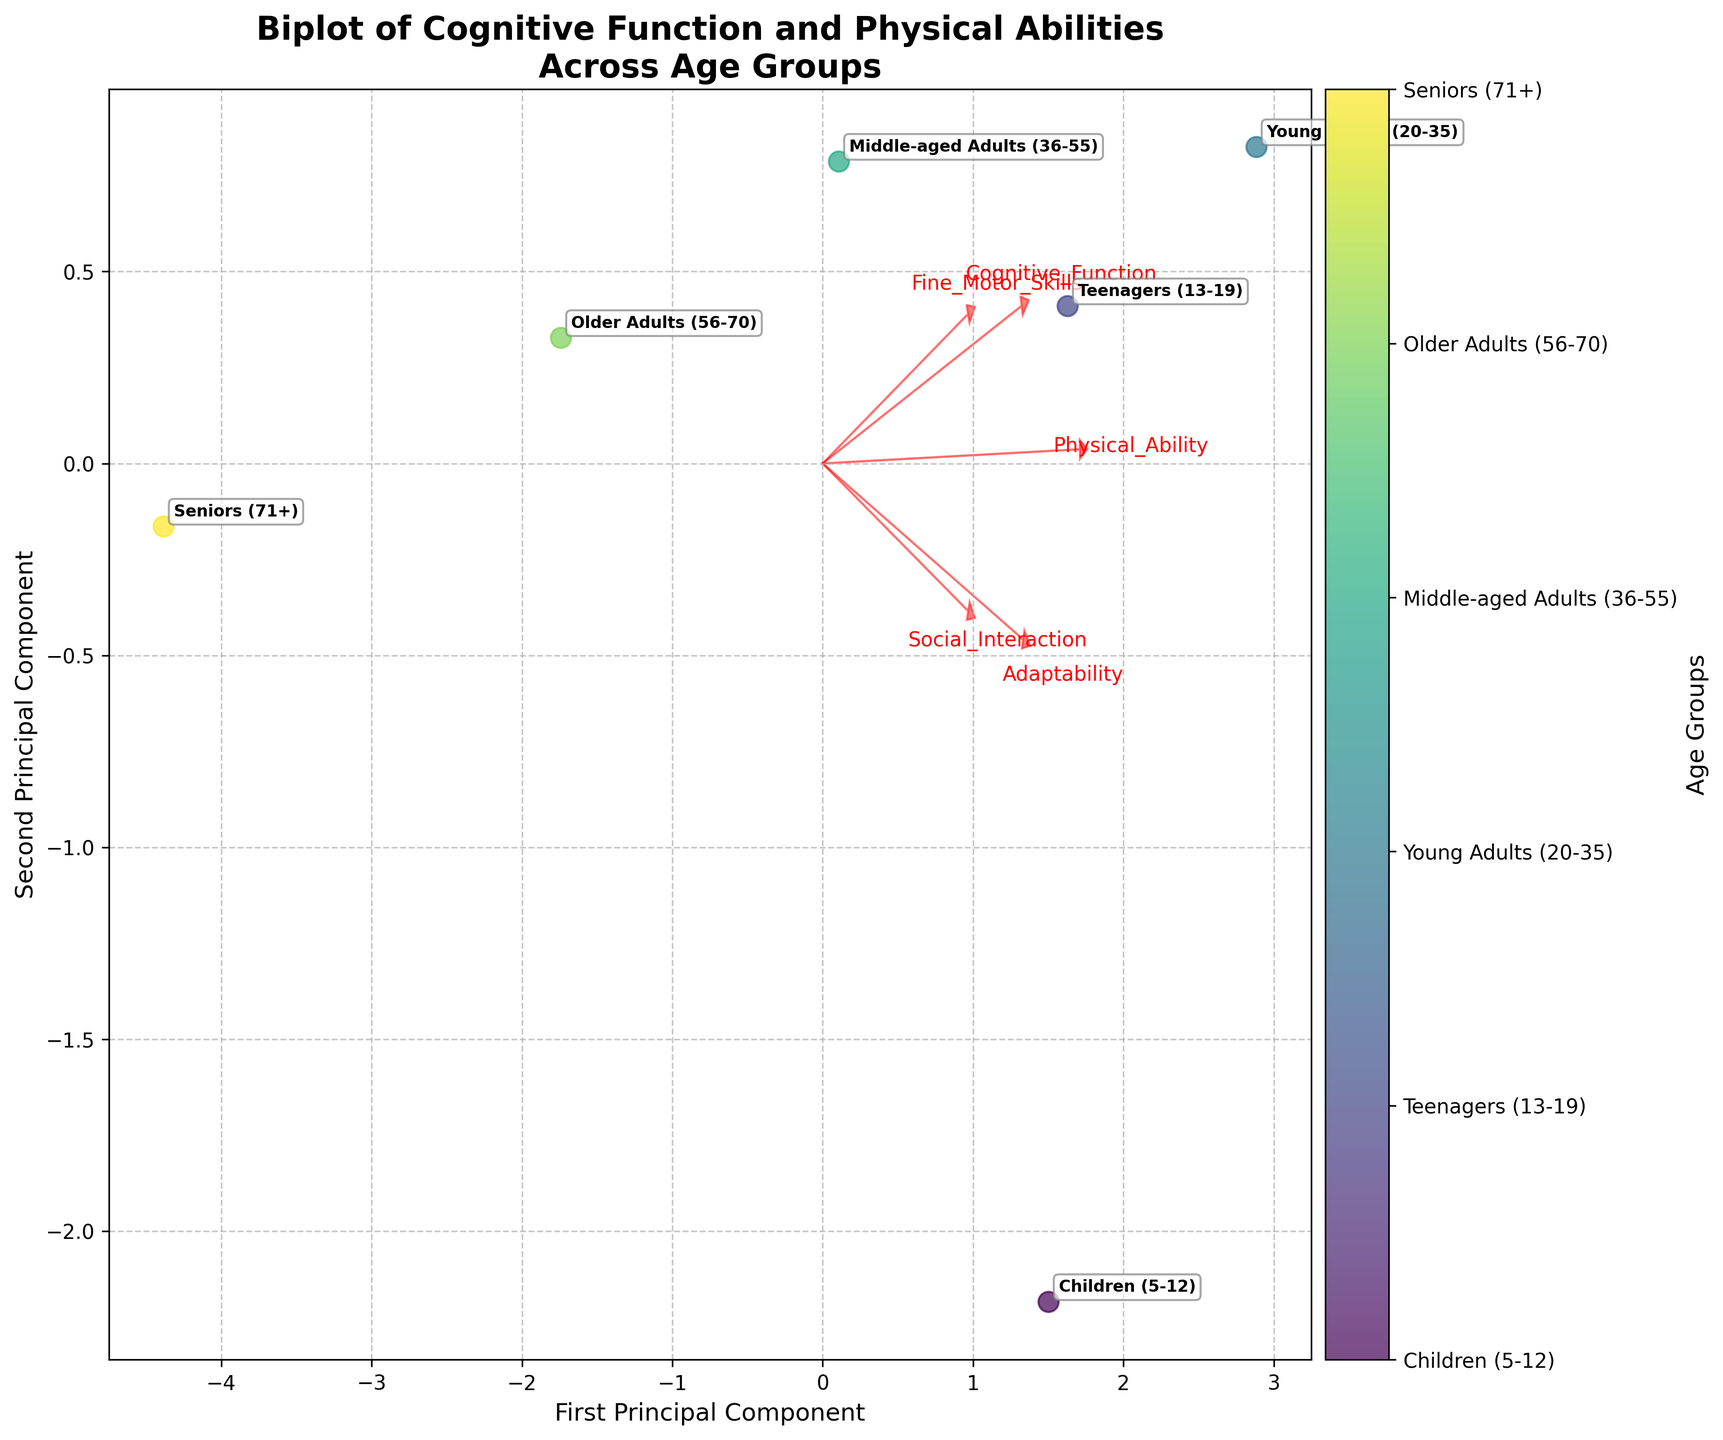What is the title of the figure? The title of the figure is found at the top and usually provides a clear idea about the data being presented. In this case, it is written in bold for emphasis.
Answer: Biplot of Cognitive Function and Physical Abilities Across Age Groups How many principal components are displayed in the plot? The axes labels indicate the number of principal components, which are derived from the PCA analysis and shown as 'First Principal Component' and 'Second Principal Component'.
Answer: Two Which age group has the highest score on the first principal component? Look at the horizontal spread of the points along the x-axis (First Principal Component). The point furthest to the right represents the highest score.
Answer: Young Adults (20-35) Which feature has the largest vector in the direction of the first principal component? Examine the arrows (feature vectors) plotted from the origin. The feature with the longest arrow extending furthest in the x-axis direction has the largest vector along the first principal component.
Answer: Cognitive Function What is the general relationship between age group and physical ability based on the biplot? Look at the position of the age groups and the direction of the Physical Ability vector. Generally, age groups to the right have higher Physical Ability scores, decreasing as you go left on the biplot.
Answer: Physical Ability generally decreases with age Which two age groups are closest to each other on the biplot? Compare the pairwise distances between the points representing different age groups on the plot. The two closest points will be the smallest visual distance apart.
Answer: Teenagers (13-19) and Young Adults (20-35) How does Social Interaction relate to Adaptability across age groups based on the feature vectors? Look at the angles between the arrows for 'Social Interaction' and 'Adaptability'. If they point in similar directions or have a small angle between them, they are positively related; if opposite, negatively related.
Answer: Positively related Which feature vector is closely aligned with the second principal component? Observe the vectors flying towards the y-axis (Second Principal Component). The closest arrow in direction and length indicates the feature aligned with the second principal component.
Answer: Fine Motor Skills Are there any age groups that have similar cognitive function but different physical abilities? Compare the positions of points on the plot along the Cognitive Function vector. Then compare the positions along the Physical Ability vector for those same points.
Answer: Middle-aged Adults (36-55) and Older Adults (56-70) Which feature vector is most orthogonal (perpendicular) to Cognitive Function? Find the arrow that forms a right angle or close to 90 degrees with the 'Cognitive Function' vector. Perpendicular vectors indicate no direct correlation.
Answer: Fine Motor Skills 